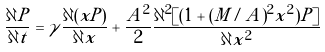Convert formula to latex. <formula><loc_0><loc_0><loc_500><loc_500>\frac { \partial P } { \partial t } = \gamma \frac { \partial ( x P ) } { \partial x } + \frac { A ^ { 2 } } { 2 } \frac { \partial ^ { 2 } [ ( 1 + ( M / A ) ^ { 2 } x ^ { 2 } ) P ] } { \partial x ^ { 2 } }</formula> 